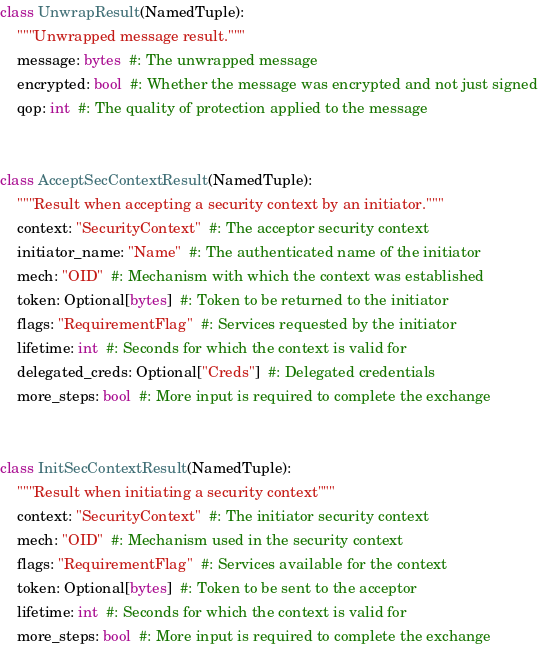Convert code to text. <code><loc_0><loc_0><loc_500><loc_500><_Python_>class UnwrapResult(NamedTuple):
    """Unwrapped message result."""
    message: bytes  #: The unwrapped message
    encrypted: bool  #: Whether the message was encrypted and not just signed
    qop: int  #: The quality of protection applied to the message


class AcceptSecContextResult(NamedTuple):
    """Result when accepting a security context by an initiator."""
    context: "SecurityContext"  #: The acceptor security context
    initiator_name: "Name"  #: The authenticated name of the initiator
    mech: "OID"  #: Mechanism with which the context was established
    token: Optional[bytes]  #: Token to be returned to the initiator
    flags: "RequirementFlag"  #: Services requested by the initiator
    lifetime: int  #: Seconds for which the context is valid for
    delegated_creds: Optional["Creds"]  #: Delegated credentials
    more_steps: bool  #: More input is required to complete the exchange


class InitSecContextResult(NamedTuple):
    """Result when initiating a security context"""
    context: "SecurityContext"  #: The initiator security context
    mech: "OID"  #: Mechanism used in the security context
    flags: "RequirementFlag"  #: Services available for the context
    token: Optional[bytes]  #: Token to be sent to the acceptor
    lifetime: int  #: Seconds for which the context is valid for
    more_steps: bool  #: More input is required to complete the exchange

</code> 